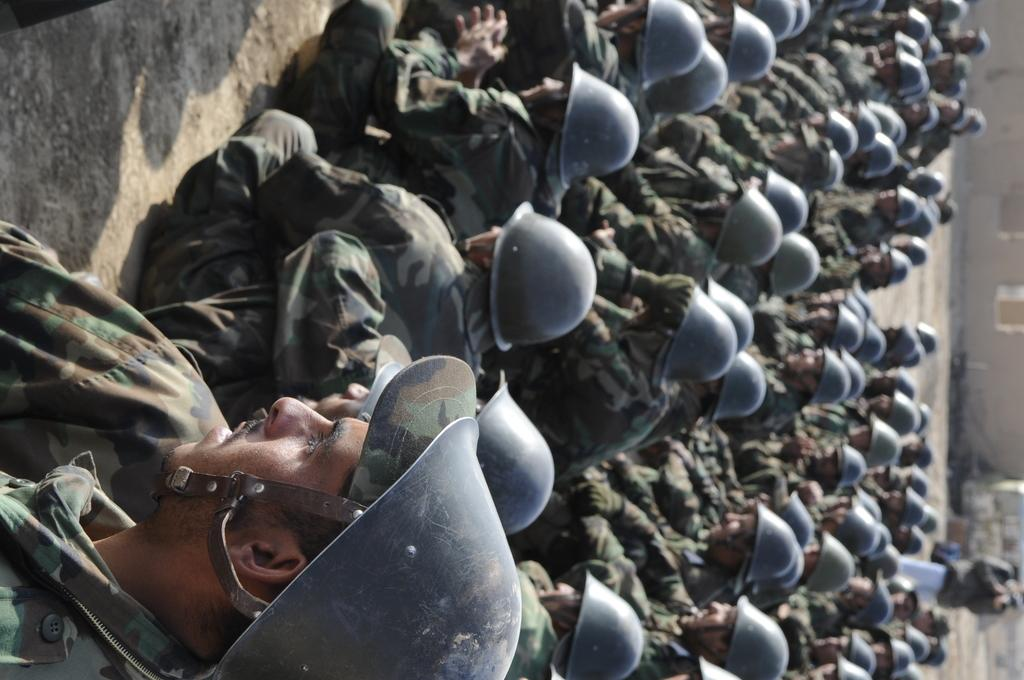What are the people in the image doing? There is a group of people sitting on the ground in the image. Who else can be seen in the image besides the group of people? There is a person standing and holding a camera in the image. What can be seen in the background of the image? There appears to be a building in the background of the image. What type of nut is being used to open the soda can in the image? There is no nut or soda can present in the image. How many icicles are hanging from the person holding the camera in the image? There are no icicles present in the image. 